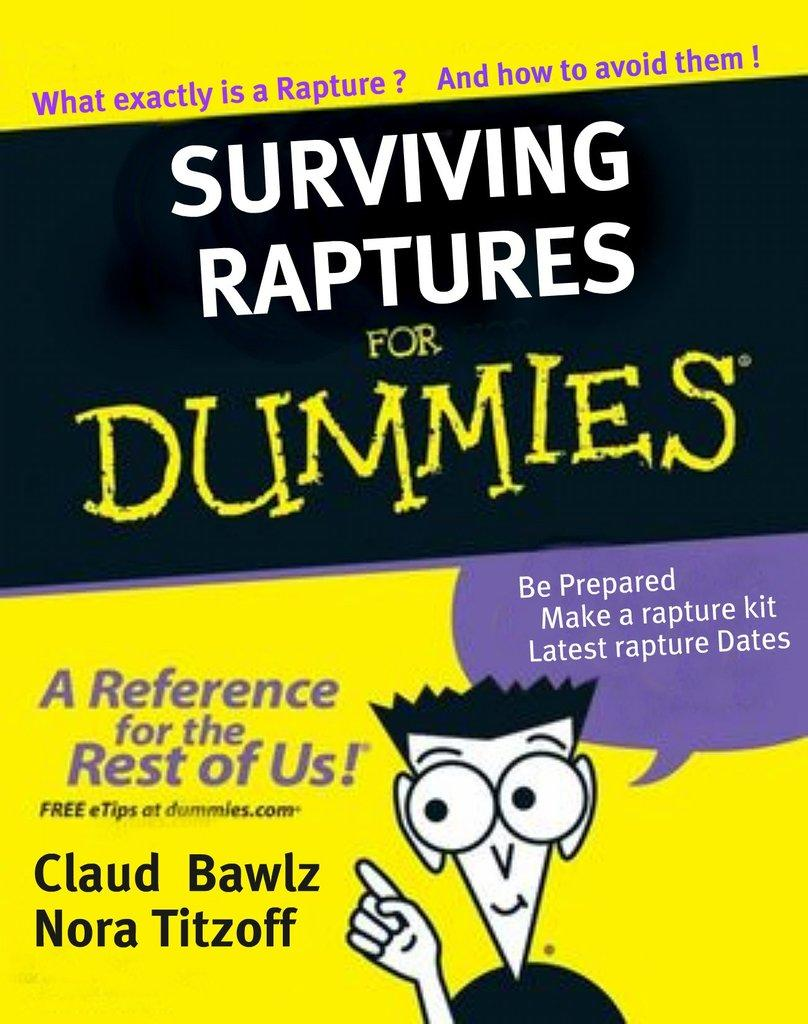Provide a one-sentence caption for the provided image. A yellow book titled Surviving Raptures for Dummies. 